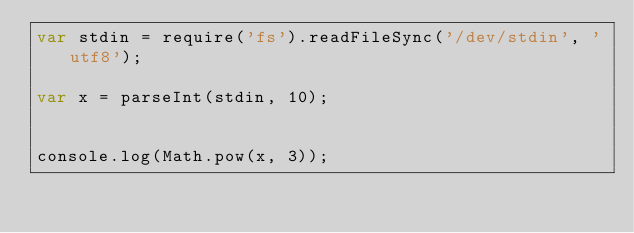<code> <loc_0><loc_0><loc_500><loc_500><_JavaScript_>var stdin = require('fs').readFileSync('/dev/stdin', 'utf8');

var x = parseInt(stdin, 10);


console.log(Math.pow(x, 3));</code> 